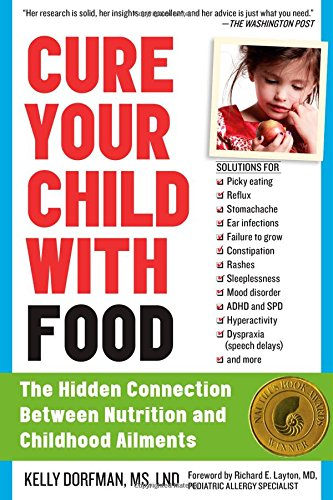Is this book related to Science Fiction & Fantasy? No, this book does not delve into the realms of Science Fiction & Fantasy. It is strictly focused on realistic, evidence-based dietary approaches to health care for children. 